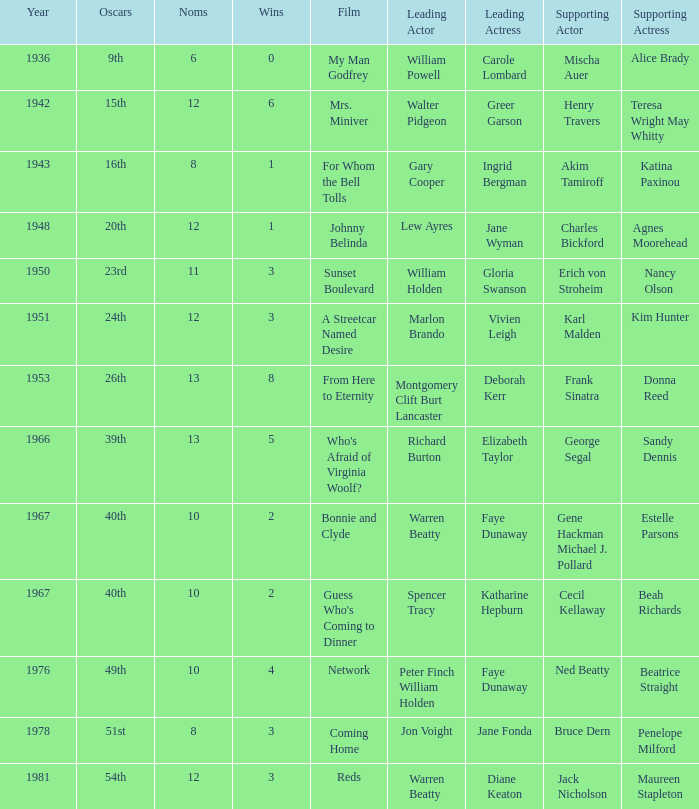Who portrayed the role of a secondary actress in a film starring diane keaton as the lead character? Maureen Stapleton. 